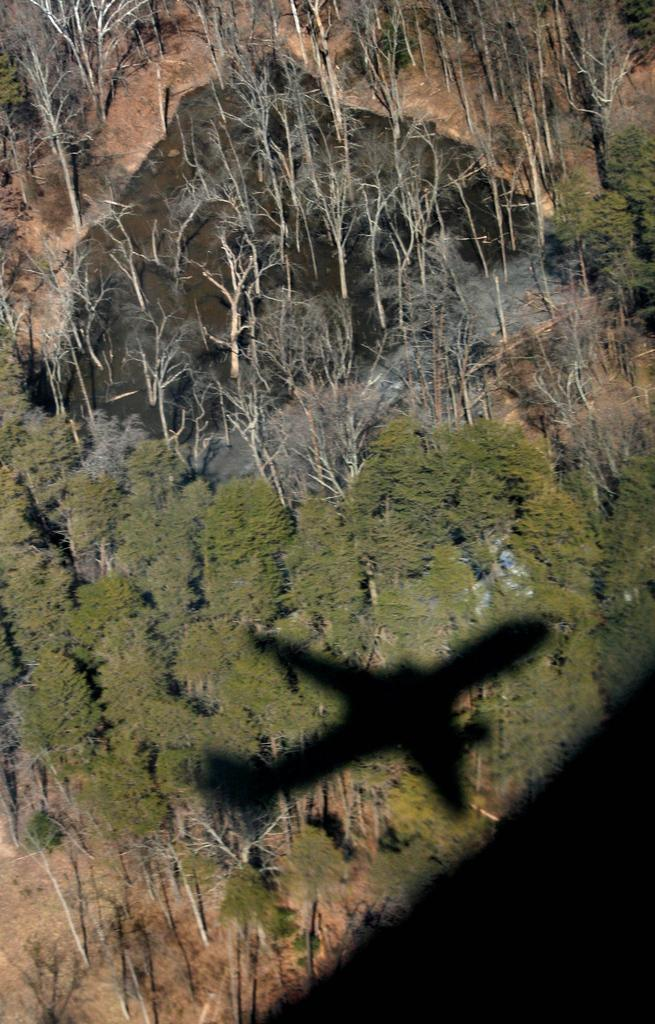What type of vegetation can be seen in the image? There are trees in the image. Where are the trees located? The trees are located in a desert. What can be observed on the trees in the image? There is an aircraft shadow displayed on the trees. What type of quilt is draped over the trees in the image? There is no quilt present in the image; it features trees in a desert with an aircraft shadow displayed on them. How many feet are visible in the image? There are no feet visible in the image. 